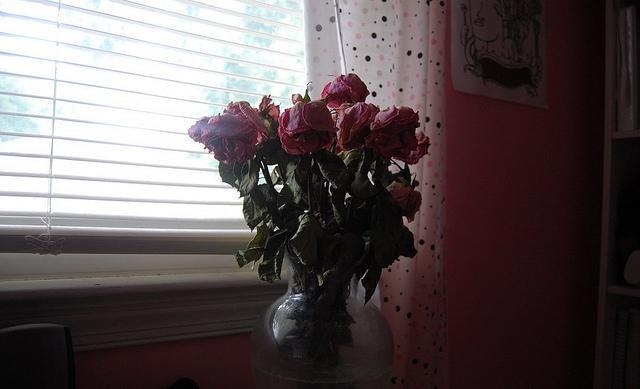How many potted plants are visible?
Give a very brief answer. 1. How many orange balloons are in the picture?
Give a very brief answer. 0. 